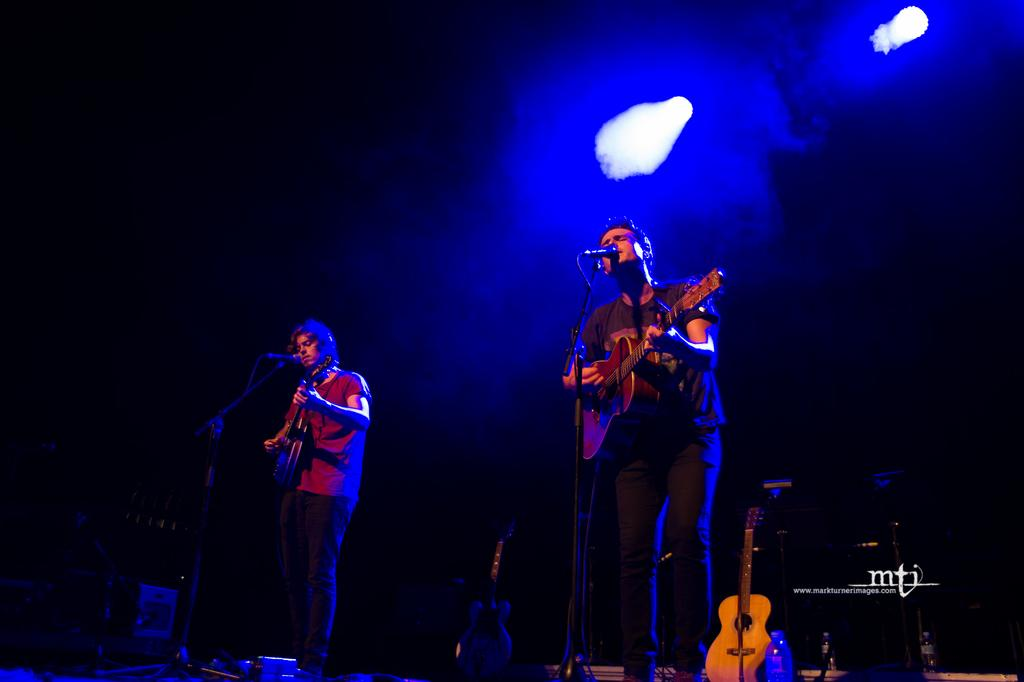How many people are in the image? There are two men in the image. What are the men doing in the image? The men are playing the guitar and singing. What object is in front of the men? There is a microphone in front of the men. What can be seen at the top of the image? There are focus lights at the top of the image. How many legs can be seen on the cats in the image? There are no cats present in the image, so the number of legs cannot be determined. 